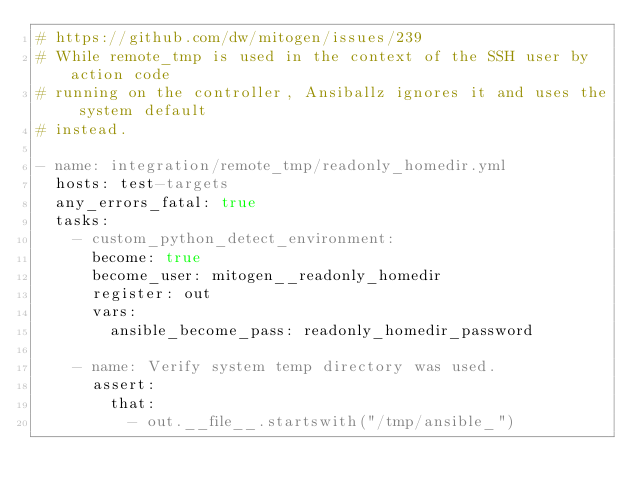<code> <loc_0><loc_0><loc_500><loc_500><_YAML_># https://github.com/dw/mitogen/issues/239
# While remote_tmp is used in the context of the SSH user by action code
# running on the controller, Ansiballz ignores it and uses the system default
# instead.

- name: integration/remote_tmp/readonly_homedir.yml
  hosts: test-targets
  any_errors_fatal: true
  tasks:
    - custom_python_detect_environment:
      become: true
      become_user: mitogen__readonly_homedir
      register: out
      vars:
        ansible_become_pass: readonly_homedir_password

    - name: Verify system temp directory was used.
      assert:
        that:
          - out.__file__.startswith("/tmp/ansible_")
</code> 